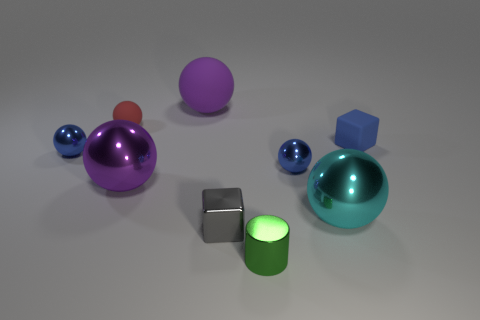What materials do the objects in the image appear to be made of? The objects in the image appear to have various materials. The balls and the large dome-shaped object have a shiny, reflective surface that suggests a metallic or glossy plastic material. The gray cubes have a matte finish, indicating they might be made of stone or a dull metal, and the green cylinder seems to have a luminous surface, possibly indicating a light-emitting material. 